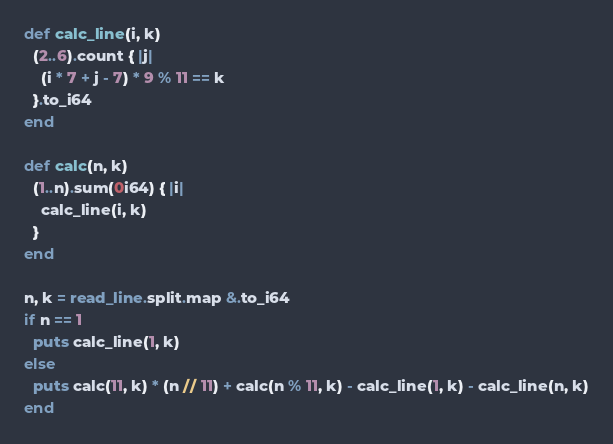<code> <loc_0><loc_0><loc_500><loc_500><_Crystal_>def calc_line(i, k)
  (2..6).count { |j|
    (i * 7 + j - 7) * 9 % 11 == k
  }.to_i64
end

def calc(n, k)
  (1..n).sum(0i64) { |i|
    calc_line(i, k)
  }
end

n, k = read_line.split.map &.to_i64
if n == 1
  puts calc_line(1, k)
else
  puts calc(11, k) * (n // 11) + calc(n % 11, k) - calc_line(1, k) - calc_line(n, k)
end</code> 